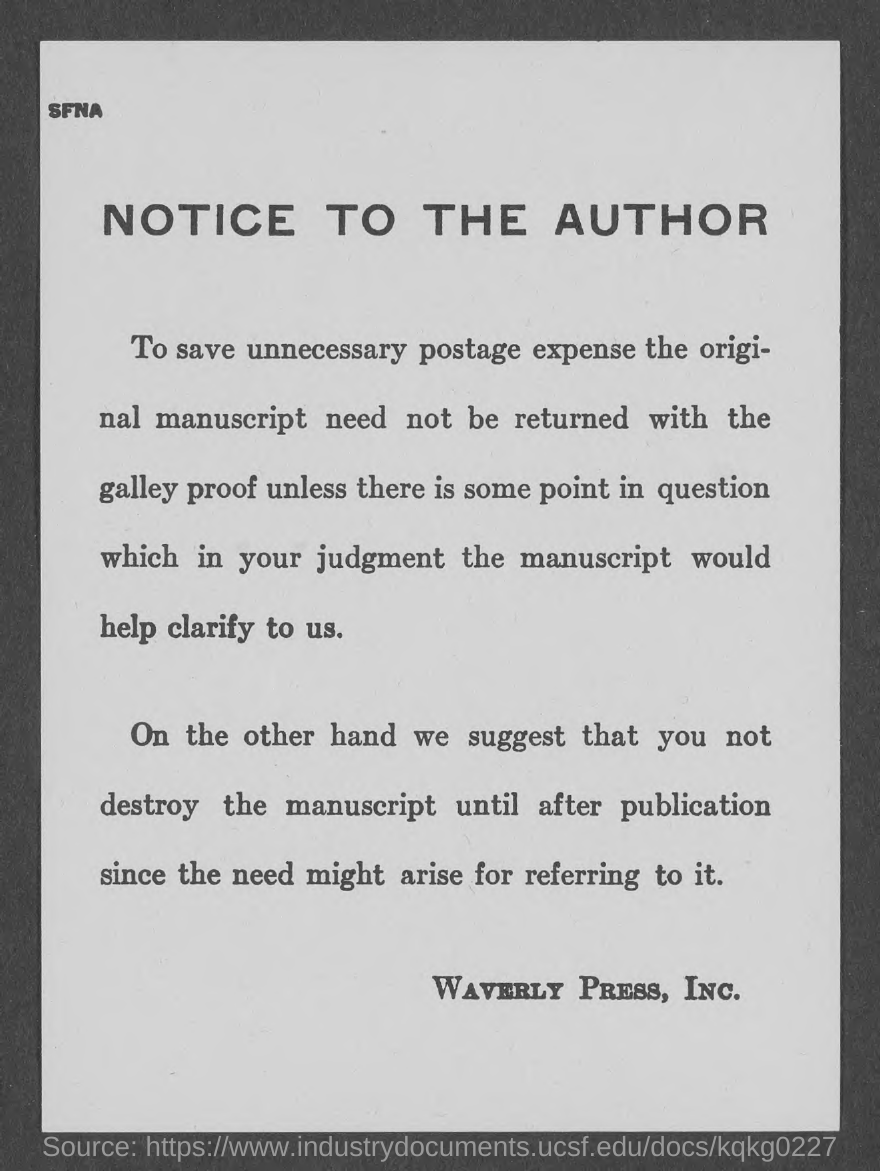What is the document title?
Offer a very short reply. NOTICE TO THE AUTHOR. Who has issued the notice?
Offer a terse response. Waverly Press, Inc. 